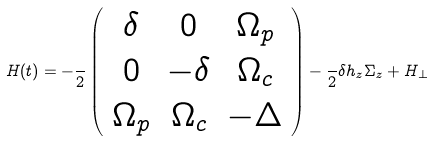Convert formula to latex. <formula><loc_0><loc_0><loc_500><loc_500>H ( t ) = - \frac { } { 2 } \left ( \begin{array} { c c c } \delta & 0 & \Omega _ { p } \\ 0 & - \delta & \Omega _ { c } \\ \Omega _ { p } & \Omega _ { c } & - \Delta \end{array} \right ) - \frac { } { 2 } \delta h _ { z } \Sigma _ { z } + H _ { \perp }</formula> 